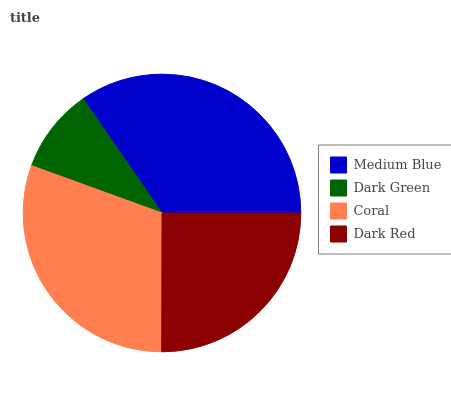Is Dark Green the minimum?
Answer yes or no. Yes. Is Medium Blue the maximum?
Answer yes or no. Yes. Is Coral the minimum?
Answer yes or no. No. Is Coral the maximum?
Answer yes or no. No. Is Coral greater than Dark Green?
Answer yes or no. Yes. Is Dark Green less than Coral?
Answer yes or no. Yes. Is Dark Green greater than Coral?
Answer yes or no. No. Is Coral less than Dark Green?
Answer yes or no. No. Is Coral the high median?
Answer yes or no. Yes. Is Dark Red the low median?
Answer yes or no. Yes. Is Dark Green the high median?
Answer yes or no. No. Is Medium Blue the low median?
Answer yes or no. No. 